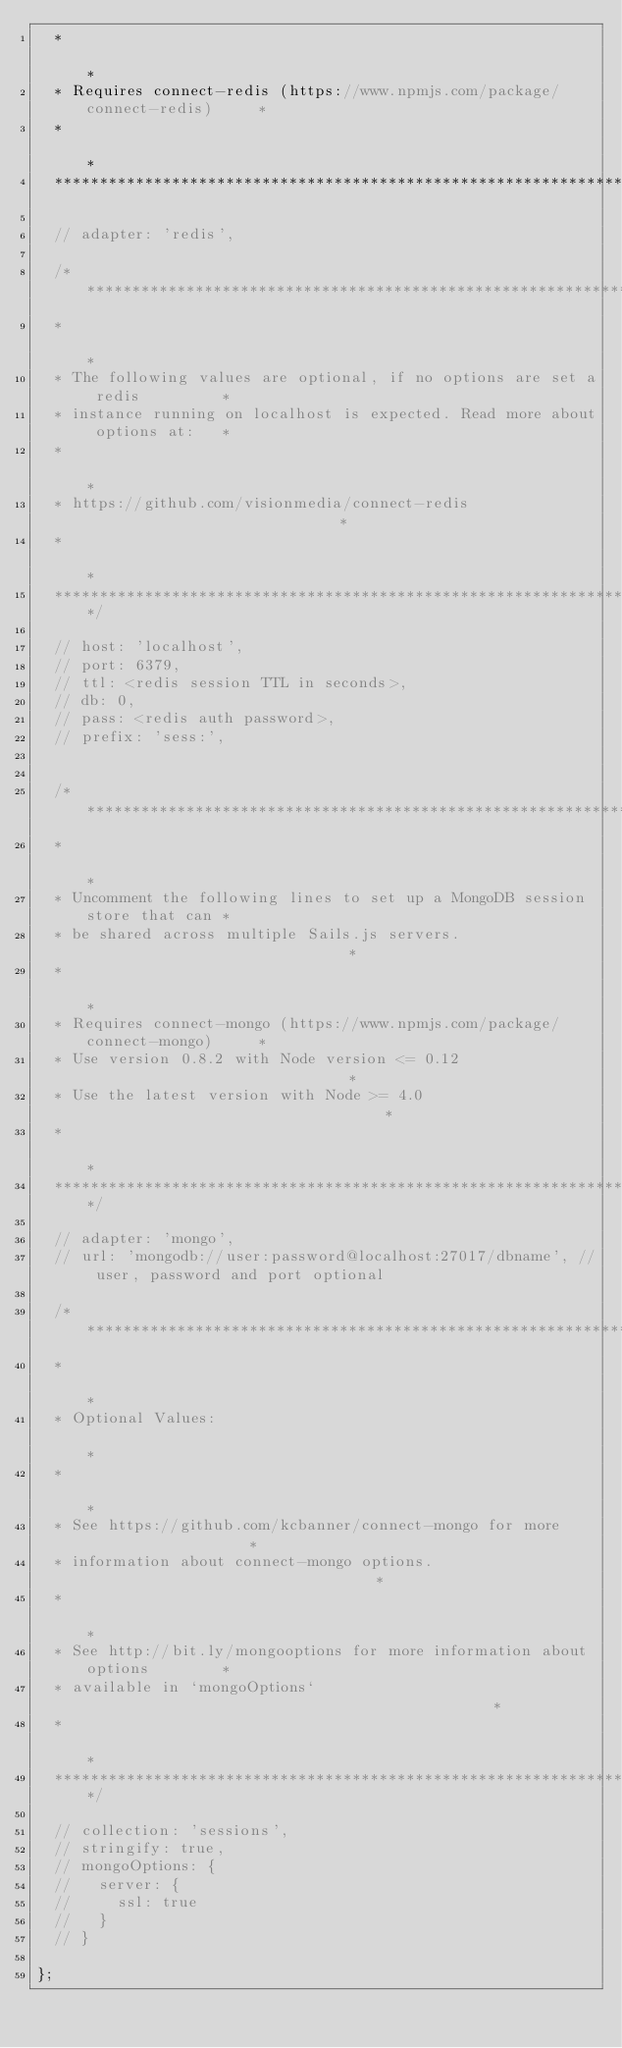Convert code to text. <code><loc_0><loc_0><loc_500><loc_500><_JavaScript_>  *                                                                          *
  * Requires connect-redis (https://www.npmjs.com/package/connect-redis)     *
  *                                                                          *
  ***************************************************************************/

  // adapter: 'redis',

  /***************************************************************************
  *                                                                          *
  * The following values are optional, if no options are set a redis         *
  * instance running on localhost is expected. Read more about options at:   *
  *                                                                          *
  * https://github.com/visionmedia/connect-redis                             *
  *                                                                          *
  ***************************************************************************/

  // host: 'localhost',
  // port: 6379,
  // ttl: <redis session TTL in seconds>,
  // db: 0,
  // pass: <redis auth password>,
  // prefix: 'sess:',


  /***************************************************************************
  *                                                                          *
  * Uncomment the following lines to set up a MongoDB session store that can *
  * be shared across multiple Sails.js servers.                              *
  *                                                                          *
  * Requires connect-mongo (https://www.npmjs.com/package/connect-mongo)     *
  * Use version 0.8.2 with Node version <= 0.12                              *
  * Use the latest version with Node >= 4.0                                  *
  *                                                                          *
  ***************************************************************************/

  // adapter: 'mongo',
  // url: 'mongodb://user:password@localhost:27017/dbname', // user, password and port optional

  /***************************************************************************
  *                                                                          *
  * Optional Values:                                                         *
  *                                                                          *
  * See https://github.com/kcbanner/connect-mongo for more                   *
  * information about connect-mongo options.                                 *
  *                                                                          *
  * See http://bit.ly/mongooptions for more information about options        *
  * available in `mongoOptions`                                              *
  *                                                                          *
  ***************************************************************************/

  // collection: 'sessions',
  // stringify: true,
  // mongoOptions: {
  //   server: {
  //     ssl: true
  //   }
  // }

};
</code> 